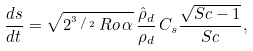<formula> <loc_0><loc_0><loc_500><loc_500>\frac { d s } { d t } = \sqrt { 2 ^ { ^ { 3 } \, / \, _ { 2 } } \, R o \, \alpha } \, \frac { \hat { \rho } _ { d } } { \rho _ { d } } \, C _ { s } \frac { \sqrt { S c - 1 } } { S c } ,</formula> 